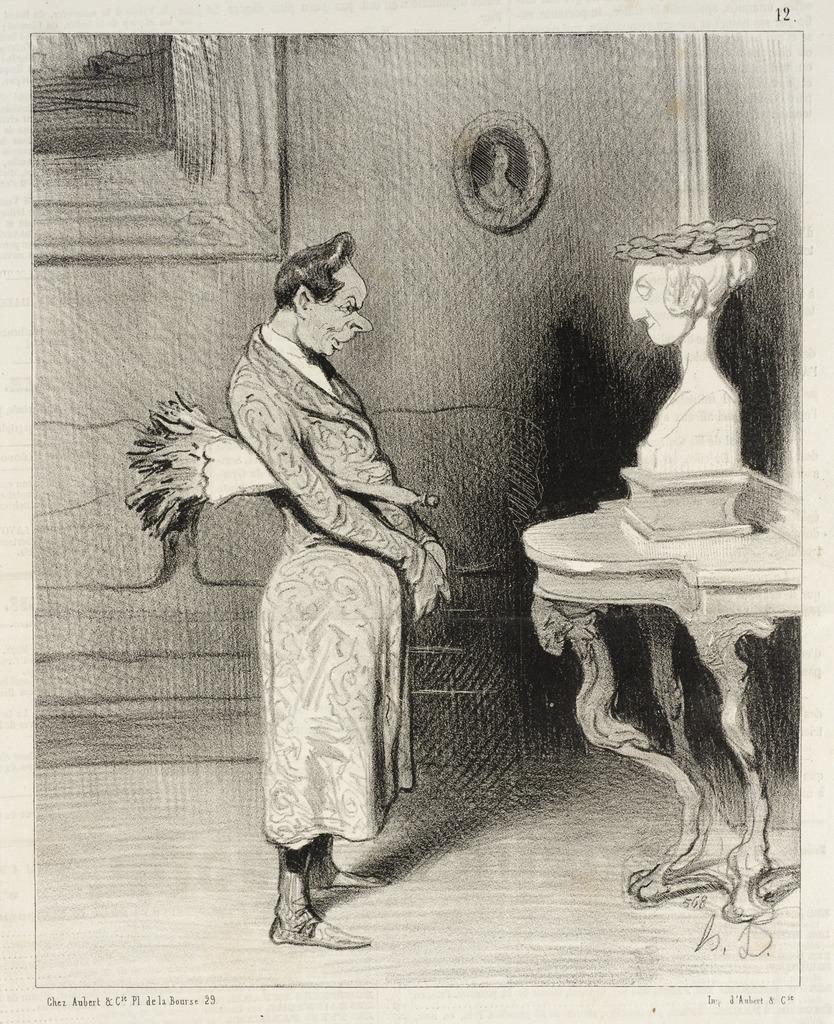Could you give a brief overview of what you see in this image? In this image I can see a drawing. I can see two photo frames. I can see a person. 